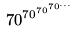Convert formula to latex. <formula><loc_0><loc_0><loc_500><loc_500>7 0 ^ { 7 0 ^ { 7 0 ^ { 7 0 ^ { \dots } } } }</formula> 